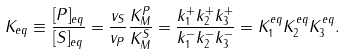Convert formula to latex. <formula><loc_0><loc_0><loc_500><loc_500>K _ { e q } \equiv \frac { [ P ] _ { e q } } { [ S ] _ { e q } } = \frac { v _ { S } } { v _ { P } } \frac { K _ { M } ^ { P } } { K _ { M } ^ { S } } = \frac { k _ { 1 } ^ { + } k _ { 2 } ^ { + } k _ { 3 } ^ { + } } { k _ { 1 } ^ { - } k _ { 2 } ^ { - } k _ { 3 } ^ { - } } = K _ { 1 } ^ { e q } K _ { 2 } ^ { e q } K _ { 3 } ^ { e q } .</formula> 